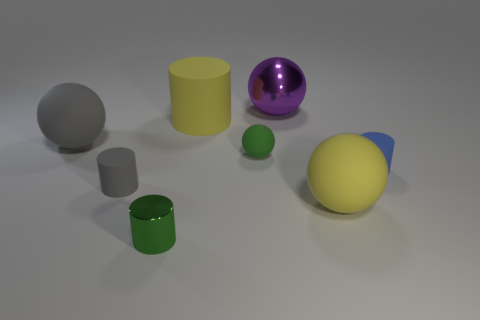Is the small green cylinder made of the same material as the big thing in front of the big gray rubber thing? While the small green cylinder and the larger object in front of the big gray object both appear smooth and reflective, suggesting a similar material composition at a glance, their different colors and potential variations in surface finish, which are not distinguishable in the image, mean we cannot conclusively determine if they are made of the identical material without more information. 